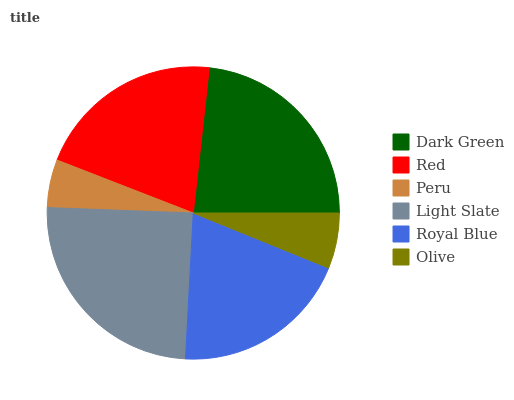Is Peru the minimum?
Answer yes or no. Yes. Is Light Slate the maximum?
Answer yes or no. Yes. Is Red the minimum?
Answer yes or no. No. Is Red the maximum?
Answer yes or no. No. Is Dark Green greater than Red?
Answer yes or no. Yes. Is Red less than Dark Green?
Answer yes or no. Yes. Is Red greater than Dark Green?
Answer yes or no. No. Is Dark Green less than Red?
Answer yes or no. No. Is Red the high median?
Answer yes or no. Yes. Is Royal Blue the low median?
Answer yes or no. Yes. Is Royal Blue the high median?
Answer yes or no. No. Is Olive the low median?
Answer yes or no. No. 